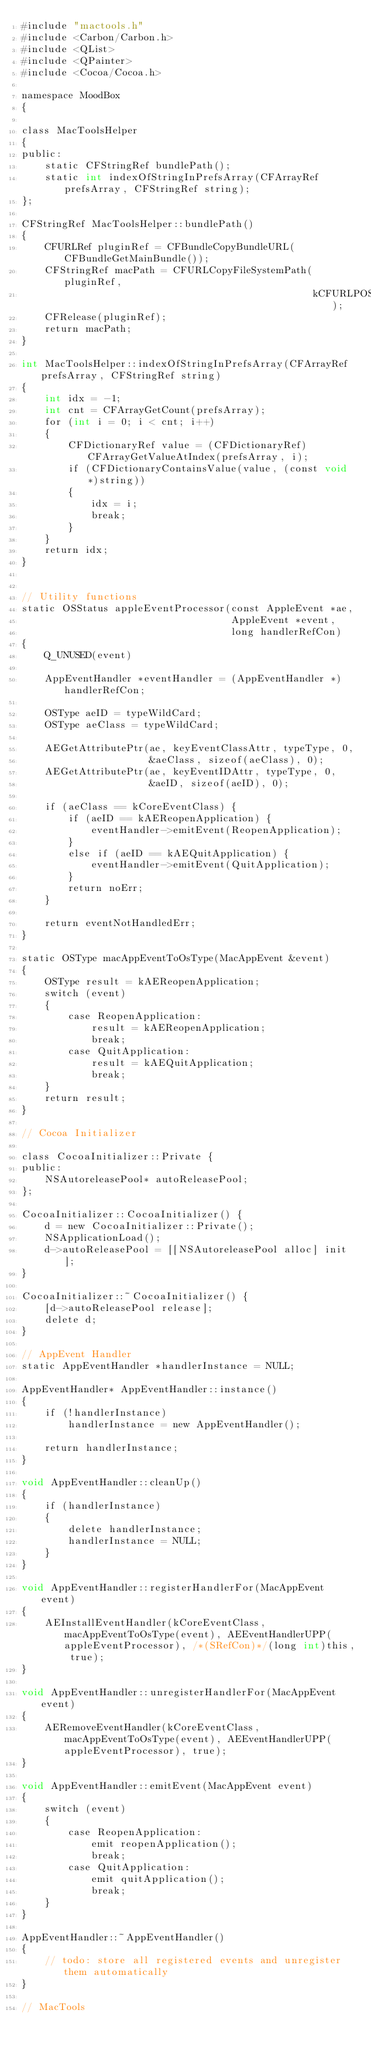Convert code to text. <code><loc_0><loc_0><loc_500><loc_500><_ObjectiveC_>#include "mactools.h"
#include <Carbon/Carbon.h>
#include <QList>
#include <QPainter>
#include <Cocoa/Cocoa.h>

namespace MoodBox 
{
   
class MacToolsHelper
{
public:
    static CFStringRef bundlePath();
    static int indexOfStringInPrefsArray(CFArrayRef prefsArray, CFStringRef string);
};
    
CFStringRef MacToolsHelper::bundlePath()
{
    CFURLRef pluginRef = CFBundleCopyBundleURL(CFBundleGetMainBundle());
    CFStringRef macPath = CFURLCopyFileSystemPath(pluginRef,
                                                  kCFURLPOSIXPathStyle);
    CFRelease(pluginRef);
    return macPath;
}

int MacToolsHelper::indexOfStringInPrefsArray(CFArrayRef prefsArray, CFStringRef string)
{
    int idx = -1;
    int cnt = CFArrayGetCount(prefsArray);
    for (int i = 0; i < cnt; i++)
    {
        CFDictionaryRef value = (CFDictionaryRef)CFArrayGetValueAtIndex(prefsArray, i);
        if (CFDictionaryContainsValue(value, (const void*)string))
        {
            idx = i;
            break;
        }
    }
    return idx;
}
    
    
// Utility functions
static OSStatus appleEventProcessor(const AppleEvent *ae,
                                    AppleEvent *event,
                                    long handlerRefCon)
{
	Q_UNUSED(event)
	
    AppEventHandler *eventHandler = (AppEventHandler *) handlerRefCon;
    
    OSType aeID = typeWildCard;
    OSType aeClass = typeWildCard;
    
    AEGetAttributePtr(ae, keyEventClassAttr, typeType, 0,
                      &aeClass, sizeof(aeClass), 0);
    AEGetAttributePtr(ae, keyEventIDAttr, typeType, 0,
                      &aeID, sizeof(aeID), 0);
    
    if (aeClass == kCoreEventClass) {
        if (aeID == kAEReopenApplication) {
            eventHandler->emitEvent(ReopenApplication);          
        }
        else if (aeID == kAEQuitApplication) {
            eventHandler->emitEvent(QuitApplication);
        }
        return noErr;
    }
    
    return eventNotHandledErr;
}
    
static OSType macAppEventToOsType(MacAppEvent &event)
{
    OSType result = kAEReopenApplication;
    switch (event)
    {
        case ReopenApplication:
            result = kAEReopenApplication;
            break;
        case QuitApplication:
            result = kAEQuitApplication;
            break;            
    }
    return result;
}
    
// Cocoa Initializer
    
class CocoaInitializer::Private {
public:
    NSAutoreleasePool* autoReleasePool;
};

CocoaInitializer::CocoaInitializer() {
    d = new CocoaInitializer::Private();
    NSApplicationLoad();
    d->autoReleasePool = [[NSAutoreleasePool alloc] init];
}

CocoaInitializer::~CocoaInitializer() {
    [d->autoReleasePool release];
    delete d;
}
       
// AppEvent Handler
static AppEventHandler *handlerInstance = NULL;    
    
AppEventHandler* AppEventHandler::instance()
{
    if (!handlerInstance)
        handlerInstance = new AppEventHandler();
    
    return handlerInstance;
}
    
void AppEventHandler::cleanUp()
{
    if (handlerInstance)
    {
        delete handlerInstance;
        handlerInstance = NULL;
    }
}
    
void AppEventHandler::registerHandlerFor(MacAppEvent event)
{
    AEInstallEventHandler(kCoreEventClass, macAppEventToOsType(event), AEEventHandlerUPP(appleEventProcessor), /*(SRefCon)*/(long int)this, true);
}
    
void AppEventHandler::unregisterHandlerFor(MacAppEvent event)
{
    AERemoveEventHandler(kCoreEventClass, macAppEventToOsType(event), AEEventHandlerUPP(appleEventProcessor), true);                
}
    
void AppEventHandler::emitEvent(MacAppEvent event) 
{
    switch (event)
    {
        case ReopenApplication:
            emit reopenApplication();
            break;
        case QuitApplication:
            emit quitApplication();
            break;
    }        
}    
    
AppEventHandler::~AppEventHandler() 
{
    // todo: store all registered events and unregister them automatically
}

// MacTools</code> 